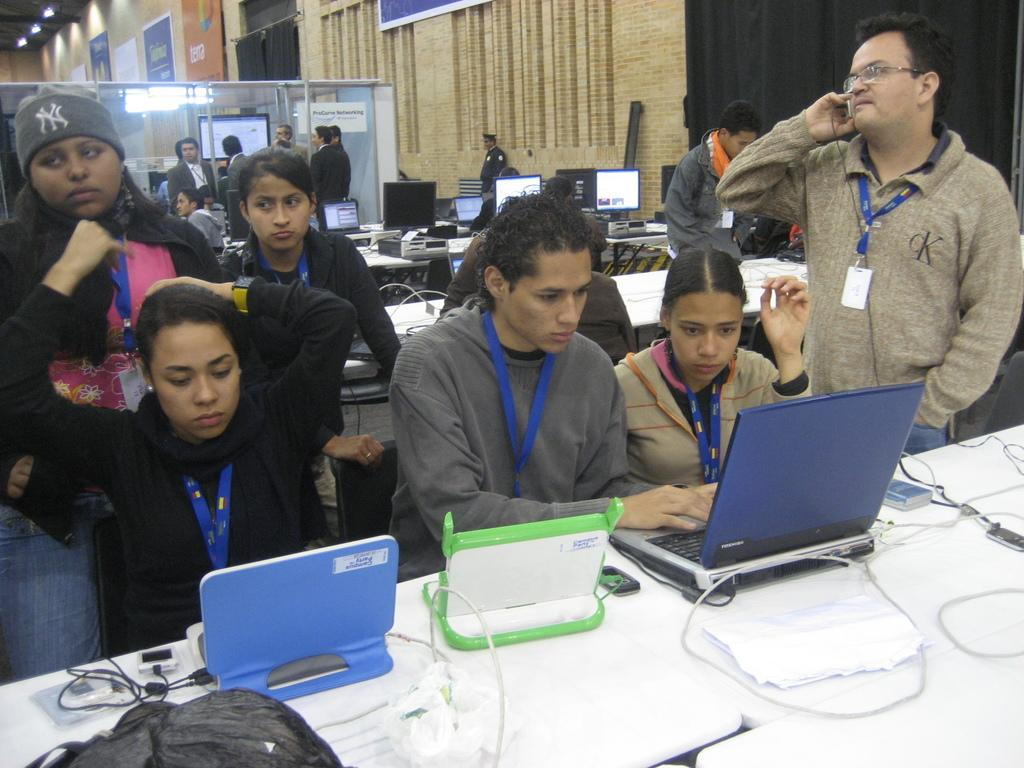What are the people in the image doing? There are people sitting and standing in the image. What objects can be seen on the desk in the image? There are electronic gadgets on a desk in the image. What type of furniture is present in the image? There are chairs in the image. What architectural feature can be seen in the image? There is a wall in the image. What type of window treatment is present in the image? There are curtains in the image. What is visible on the ceiling in the image? There is a ceiling with lights in the image. Can you see a duck in the image? There is no duck present in the image. What type of dog is sitting next to the people in the image? There is no dog present in the image. 